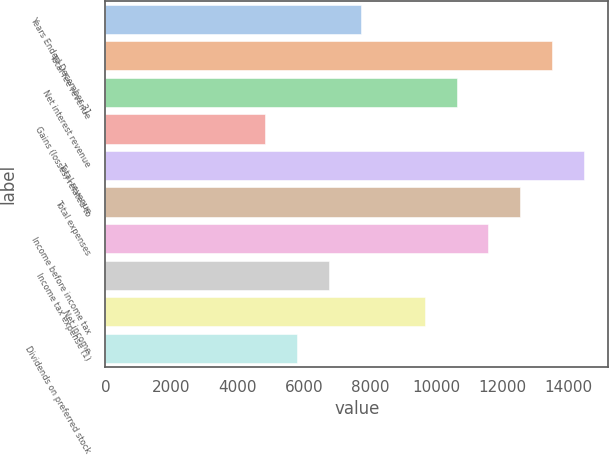Convert chart. <chart><loc_0><loc_0><loc_500><loc_500><bar_chart><fcel>Years Ended December 31<fcel>Total fee revenue<fcel>Net interest revenue<fcel>Gains (losses) related to<fcel>Total revenue<fcel>Total expenses<fcel>Income before income tax<fcel>Income tax expense (1)<fcel>Net income<fcel>Dividends on preferred stock<nl><fcel>7719.36<fcel>13508.2<fcel>10613.8<fcel>4824.96<fcel>14473<fcel>12543.4<fcel>11578.6<fcel>6754.56<fcel>9648.96<fcel>5789.76<nl></chart> 